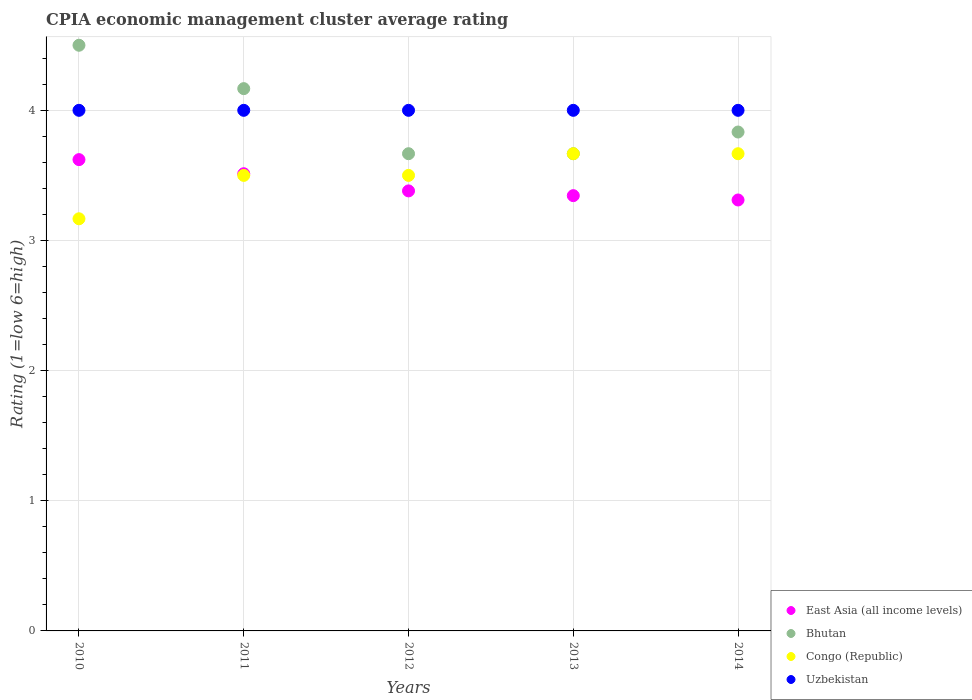How many different coloured dotlines are there?
Give a very brief answer. 4. Is the number of dotlines equal to the number of legend labels?
Make the answer very short. Yes. Across all years, what is the maximum CPIA rating in Uzbekistan?
Provide a succinct answer. 4. Across all years, what is the minimum CPIA rating in Bhutan?
Offer a very short reply. 3.67. In which year was the CPIA rating in Uzbekistan minimum?
Your answer should be very brief. 2010. What is the difference between the CPIA rating in Uzbekistan in 2012 and that in 2014?
Your answer should be compact. 0. What is the difference between the CPIA rating in Bhutan in 2011 and the CPIA rating in Uzbekistan in 2014?
Keep it short and to the point. 0.17. What is the average CPIA rating in Uzbekistan per year?
Your answer should be very brief. 4. In the year 2011, what is the difference between the CPIA rating in Uzbekistan and CPIA rating in Bhutan?
Your response must be concise. -0.17. What is the difference between the highest and the second highest CPIA rating in Uzbekistan?
Offer a very short reply. 0. What is the difference between the highest and the lowest CPIA rating in East Asia (all income levels)?
Your answer should be compact. 0.31. In how many years, is the CPIA rating in Uzbekistan greater than the average CPIA rating in Uzbekistan taken over all years?
Make the answer very short. 0. Is the sum of the CPIA rating in Uzbekistan in 2010 and 2012 greater than the maximum CPIA rating in Bhutan across all years?
Your answer should be compact. Yes. Does the CPIA rating in Uzbekistan monotonically increase over the years?
Make the answer very short. No. Is the CPIA rating in Uzbekistan strictly greater than the CPIA rating in Congo (Republic) over the years?
Provide a short and direct response. Yes. Is the CPIA rating in East Asia (all income levels) strictly less than the CPIA rating in Congo (Republic) over the years?
Make the answer very short. No. How many dotlines are there?
Your answer should be very brief. 4. How many years are there in the graph?
Your answer should be compact. 5. What is the difference between two consecutive major ticks on the Y-axis?
Offer a terse response. 1. What is the title of the graph?
Give a very brief answer. CPIA economic management cluster average rating. Does "Austria" appear as one of the legend labels in the graph?
Your response must be concise. No. What is the label or title of the X-axis?
Offer a terse response. Years. What is the label or title of the Y-axis?
Offer a terse response. Rating (1=low 6=high). What is the Rating (1=low 6=high) of East Asia (all income levels) in 2010?
Make the answer very short. 3.62. What is the Rating (1=low 6=high) in Bhutan in 2010?
Give a very brief answer. 4.5. What is the Rating (1=low 6=high) in Congo (Republic) in 2010?
Offer a very short reply. 3.17. What is the Rating (1=low 6=high) of Uzbekistan in 2010?
Your answer should be very brief. 4. What is the Rating (1=low 6=high) in East Asia (all income levels) in 2011?
Your answer should be compact. 3.51. What is the Rating (1=low 6=high) in Bhutan in 2011?
Your response must be concise. 4.17. What is the Rating (1=low 6=high) of Congo (Republic) in 2011?
Keep it short and to the point. 3.5. What is the Rating (1=low 6=high) in East Asia (all income levels) in 2012?
Your answer should be very brief. 3.38. What is the Rating (1=low 6=high) in Bhutan in 2012?
Your response must be concise. 3.67. What is the Rating (1=low 6=high) of Uzbekistan in 2012?
Make the answer very short. 4. What is the Rating (1=low 6=high) of East Asia (all income levels) in 2013?
Provide a short and direct response. 3.34. What is the Rating (1=low 6=high) of Bhutan in 2013?
Offer a terse response. 3.67. What is the Rating (1=low 6=high) of Congo (Republic) in 2013?
Keep it short and to the point. 3.67. What is the Rating (1=low 6=high) in East Asia (all income levels) in 2014?
Offer a very short reply. 3.31. What is the Rating (1=low 6=high) in Bhutan in 2014?
Offer a terse response. 3.83. What is the Rating (1=low 6=high) of Congo (Republic) in 2014?
Offer a terse response. 3.67. Across all years, what is the maximum Rating (1=low 6=high) of East Asia (all income levels)?
Provide a succinct answer. 3.62. Across all years, what is the maximum Rating (1=low 6=high) of Bhutan?
Your response must be concise. 4.5. Across all years, what is the maximum Rating (1=low 6=high) in Congo (Republic)?
Keep it short and to the point. 3.67. Across all years, what is the minimum Rating (1=low 6=high) of East Asia (all income levels)?
Provide a succinct answer. 3.31. Across all years, what is the minimum Rating (1=low 6=high) in Bhutan?
Ensure brevity in your answer.  3.67. Across all years, what is the minimum Rating (1=low 6=high) in Congo (Republic)?
Your answer should be compact. 3.17. What is the total Rating (1=low 6=high) of East Asia (all income levels) in the graph?
Offer a very short reply. 17.17. What is the total Rating (1=low 6=high) of Bhutan in the graph?
Keep it short and to the point. 19.83. What is the total Rating (1=low 6=high) of Uzbekistan in the graph?
Provide a short and direct response. 20. What is the difference between the Rating (1=low 6=high) in East Asia (all income levels) in 2010 and that in 2011?
Offer a very short reply. 0.11. What is the difference between the Rating (1=low 6=high) in Bhutan in 2010 and that in 2011?
Ensure brevity in your answer.  0.33. What is the difference between the Rating (1=low 6=high) of East Asia (all income levels) in 2010 and that in 2012?
Provide a short and direct response. 0.24. What is the difference between the Rating (1=low 6=high) of Bhutan in 2010 and that in 2012?
Ensure brevity in your answer.  0.83. What is the difference between the Rating (1=low 6=high) of East Asia (all income levels) in 2010 and that in 2013?
Your answer should be compact. 0.28. What is the difference between the Rating (1=low 6=high) in Bhutan in 2010 and that in 2013?
Provide a succinct answer. 0.83. What is the difference between the Rating (1=low 6=high) in Congo (Republic) in 2010 and that in 2013?
Your response must be concise. -0.5. What is the difference between the Rating (1=low 6=high) in Uzbekistan in 2010 and that in 2013?
Offer a terse response. 0. What is the difference between the Rating (1=low 6=high) of East Asia (all income levels) in 2010 and that in 2014?
Your response must be concise. 0.31. What is the difference between the Rating (1=low 6=high) in Bhutan in 2010 and that in 2014?
Ensure brevity in your answer.  0.67. What is the difference between the Rating (1=low 6=high) of East Asia (all income levels) in 2011 and that in 2012?
Give a very brief answer. 0.13. What is the difference between the Rating (1=low 6=high) of Bhutan in 2011 and that in 2012?
Provide a short and direct response. 0.5. What is the difference between the Rating (1=low 6=high) in Congo (Republic) in 2011 and that in 2012?
Offer a terse response. 0. What is the difference between the Rating (1=low 6=high) of Uzbekistan in 2011 and that in 2012?
Make the answer very short. 0. What is the difference between the Rating (1=low 6=high) of East Asia (all income levels) in 2011 and that in 2013?
Ensure brevity in your answer.  0.17. What is the difference between the Rating (1=low 6=high) in Bhutan in 2011 and that in 2013?
Offer a terse response. 0.5. What is the difference between the Rating (1=low 6=high) of East Asia (all income levels) in 2011 and that in 2014?
Offer a very short reply. 0.2. What is the difference between the Rating (1=low 6=high) in East Asia (all income levels) in 2012 and that in 2013?
Your response must be concise. 0.04. What is the difference between the Rating (1=low 6=high) in Bhutan in 2012 and that in 2013?
Make the answer very short. 0. What is the difference between the Rating (1=low 6=high) in Congo (Republic) in 2012 and that in 2013?
Provide a succinct answer. -0.17. What is the difference between the Rating (1=low 6=high) of East Asia (all income levels) in 2012 and that in 2014?
Ensure brevity in your answer.  0.07. What is the difference between the Rating (1=low 6=high) in Uzbekistan in 2012 and that in 2014?
Offer a very short reply. 0. What is the difference between the Rating (1=low 6=high) in East Asia (all income levels) in 2010 and the Rating (1=low 6=high) in Bhutan in 2011?
Provide a short and direct response. -0.55. What is the difference between the Rating (1=low 6=high) in East Asia (all income levels) in 2010 and the Rating (1=low 6=high) in Congo (Republic) in 2011?
Ensure brevity in your answer.  0.12. What is the difference between the Rating (1=low 6=high) of East Asia (all income levels) in 2010 and the Rating (1=low 6=high) of Uzbekistan in 2011?
Your response must be concise. -0.38. What is the difference between the Rating (1=low 6=high) in Bhutan in 2010 and the Rating (1=low 6=high) in Uzbekistan in 2011?
Provide a short and direct response. 0.5. What is the difference between the Rating (1=low 6=high) of East Asia (all income levels) in 2010 and the Rating (1=low 6=high) of Bhutan in 2012?
Your answer should be compact. -0.05. What is the difference between the Rating (1=low 6=high) of East Asia (all income levels) in 2010 and the Rating (1=low 6=high) of Congo (Republic) in 2012?
Keep it short and to the point. 0.12. What is the difference between the Rating (1=low 6=high) in East Asia (all income levels) in 2010 and the Rating (1=low 6=high) in Uzbekistan in 2012?
Your response must be concise. -0.38. What is the difference between the Rating (1=low 6=high) of Bhutan in 2010 and the Rating (1=low 6=high) of Congo (Republic) in 2012?
Offer a terse response. 1. What is the difference between the Rating (1=low 6=high) in Bhutan in 2010 and the Rating (1=low 6=high) in Uzbekistan in 2012?
Your answer should be compact. 0.5. What is the difference between the Rating (1=low 6=high) of Congo (Republic) in 2010 and the Rating (1=low 6=high) of Uzbekistan in 2012?
Give a very brief answer. -0.83. What is the difference between the Rating (1=low 6=high) of East Asia (all income levels) in 2010 and the Rating (1=low 6=high) of Bhutan in 2013?
Offer a terse response. -0.05. What is the difference between the Rating (1=low 6=high) of East Asia (all income levels) in 2010 and the Rating (1=low 6=high) of Congo (Republic) in 2013?
Keep it short and to the point. -0.05. What is the difference between the Rating (1=low 6=high) of East Asia (all income levels) in 2010 and the Rating (1=low 6=high) of Uzbekistan in 2013?
Your answer should be very brief. -0.38. What is the difference between the Rating (1=low 6=high) in East Asia (all income levels) in 2010 and the Rating (1=low 6=high) in Bhutan in 2014?
Your answer should be very brief. -0.21. What is the difference between the Rating (1=low 6=high) of East Asia (all income levels) in 2010 and the Rating (1=low 6=high) of Congo (Republic) in 2014?
Offer a terse response. -0.05. What is the difference between the Rating (1=low 6=high) in East Asia (all income levels) in 2010 and the Rating (1=low 6=high) in Uzbekistan in 2014?
Offer a terse response. -0.38. What is the difference between the Rating (1=low 6=high) in Bhutan in 2010 and the Rating (1=low 6=high) in Congo (Republic) in 2014?
Your answer should be very brief. 0.83. What is the difference between the Rating (1=low 6=high) of Bhutan in 2010 and the Rating (1=low 6=high) of Uzbekistan in 2014?
Offer a very short reply. 0.5. What is the difference between the Rating (1=low 6=high) in East Asia (all income levels) in 2011 and the Rating (1=low 6=high) in Bhutan in 2012?
Keep it short and to the point. -0.15. What is the difference between the Rating (1=low 6=high) in East Asia (all income levels) in 2011 and the Rating (1=low 6=high) in Congo (Republic) in 2012?
Your answer should be very brief. 0.01. What is the difference between the Rating (1=low 6=high) in East Asia (all income levels) in 2011 and the Rating (1=low 6=high) in Uzbekistan in 2012?
Give a very brief answer. -0.49. What is the difference between the Rating (1=low 6=high) in Bhutan in 2011 and the Rating (1=low 6=high) in Uzbekistan in 2012?
Your answer should be compact. 0.17. What is the difference between the Rating (1=low 6=high) in East Asia (all income levels) in 2011 and the Rating (1=low 6=high) in Bhutan in 2013?
Offer a terse response. -0.15. What is the difference between the Rating (1=low 6=high) in East Asia (all income levels) in 2011 and the Rating (1=low 6=high) in Congo (Republic) in 2013?
Provide a short and direct response. -0.15. What is the difference between the Rating (1=low 6=high) in East Asia (all income levels) in 2011 and the Rating (1=low 6=high) in Uzbekistan in 2013?
Keep it short and to the point. -0.49. What is the difference between the Rating (1=low 6=high) of Bhutan in 2011 and the Rating (1=low 6=high) of Congo (Republic) in 2013?
Offer a terse response. 0.5. What is the difference between the Rating (1=low 6=high) in East Asia (all income levels) in 2011 and the Rating (1=low 6=high) in Bhutan in 2014?
Give a very brief answer. -0.32. What is the difference between the Rating (1=low 6=high) of East Asia (all income levels) in 2011 and the Rating (1=low 6=high) of Congo (Republic) in 2014?
Make the answer very short. -0.15. What is the difference between the Rating (1=low 6=high) in East Asia (all income levels) in 2011 and the Rating (1=low 6=high) in Uzbekistan in 2014?
Keep it short and to the point. -0.49. What is the difference between the Rating (1=low 6=high) of East Asia (all income levels) in 2012 and the Rating (1=low 6=high) of Bhutan in 2013?
Offer a very short reply. -0.29. What is the difference between the Rating (1=low 6=high) of East Asia (all income levels) in 2012 and the Rating (1=low 6=high) of Congo (Republic) in 2013?
Offer a very short reply. -0.29. What is the difference between the Rating (1=low 6=high) in East Asia (all income levels) in 2012 and the Rating (1=low 6=high) in Uzbekistan in 2013?
Offer a very short reply. -0.62. What is the difference between the Rating (1=low 6=high) in Bhutan in 2012 and the Rating (1=low 6=high) in Uzbekistan in 2013?
Your response must be concise. -0.33. What is the difference between the Rating (1=low 6=high) of Congo (Republic) in 2012 and the Rating (1=low 6=high) of Uzbekistan in 2013?
Keep it short and to the point. -0.5. What is the difference between the Rating (1=low 6=high) of East Asia (all income levels) in 2012 and the Rating (1=low 6=high) of Bhutan in 2014?
Provide a succinct answer. -0.45. What is the difference between the Rating (1=low 6=high) of East Asia (all income levels) in 2012 and the Rating (1=low 6=high) of Congo (Republic) in 2014?
Your response must be concise. -0.29. What is the difference between the Rating (1=low 6=high) of East Asia (all income levels) in 2012 and the Rating (1=low 6=high) of Uzbekistan in 2014?
Your answer should be very brief. -0.62. What is the difference between the Rating (1=low 6=high) of Congo (Republic) in 2012 and the Rating (1=low 6=high) of Uzbekistan in 2014?
Provide a short and direct response. -0.5. What is the difference between the Rating (1=low 6=high) in East Asia (all income levels) in 2013 and the Rating (1=low 6=high) in Bhutan in 2014?
Keep it short and to the point. -0.49. What is the difference between the Rating (1=low 6=high) of East Asia (all income levels) in 2013 and the Rating (1=low 6=high) of Congo (Republic) in 2014?
Keep it short and to the point. -0.32. What is the difference between the Rating (1=low 6=high) of East Asia (all income levels) in 2013 and the Rating (1=low 6=high) of Uzbekistan in 2014?
Ensure brevity in your answer.  -0.66. What is the difference between the Rating (1=low 6=high) in Bhutan in 2013 and the Rating (1=low 6=high) in Uzbekistan in 2014?
Offer a very short reply. -0.33. What is the difference between the Rating (1=low 6=high) in Congo (Republic) in 2013 and the Rating (1=low 6=high) in Uzbekistan in 2014?
Your response must be concise. -0.33. What is the average Rating (1=low 6=high) of East Asia (all income levels) per year?
Offer a terse response. 3.43. What is the average Rating (1=low 6=high) in Bhutan per year?
Your answer should be compact. 3.97. What is the average Rating (1=low 6=high) of Congo (Republic) per year?
Offer a terse response. 3.5. In the year 2010, what is the difference between the Rating (1=low 6=high) of East Asia (all income levels) and Rating (1=low 6=high) of Bhutan?
Offer a very short reply. -0.88. In the year 2010, what is the difference between the Rating (1=low 6=high) of East Asia (all income levels) and Rating (1=low 6=high) of Congo (Republic)?
Your answer should be very brief. 0.45. In the year 2010, what is the difference between the Rating (1=low 6=high) in East Asia (all income levels) and Rating (1=low 6=high) in Uzbekistan?
Your response must be concise. -0.38. In the year 2010, what is the difference between the Rating (1=low 6=high) in Congo (Republic) and Rating (1=low 6=high) in Uzbekistan?
Your answer should be compact. -0.83. In the year 2011, what is the difference between the Rating (1=low 6=high) of East Asia (all income levels) and Rating (1=low 6=high) of Bhutan?
Provide a short and direct response. -0.65. In the year 2011, what is the difference between the Rating (1=low 6=high) in East Asia (all income levels) and Rating (1=low 6=high) in Congo (Republic)?
Offer a very short reply. 0.01. In the year 2011, what is the difference between the Rating (1=low 6=high) of East Asia (all income levels) and Rating (1=low 6=high) of Uzbekistan?
Your answer should be very brief. -0.49. In the year 2011, what is the difference between the Rating (1=low 6=high) of Congo (Republic) and Rating (1=low 6=high) of Uzbekistan?
Ensure brevity in your answer.  -0.5. In the year 2012, what is the difference between the Rating (1=low 6=high) in East Asia (all income levels) and Rating (1=low 6=high) in Bhutan?
Make the answer very short. -0.29. In the year 2012, what is the difference between the Rating (1=low 6=high) of East Asia (all income levels) and Rating (1=low 6=high) of Congo (Republic)?
Provide a succinct answer. -0.12. In the year 2012, what is the difference between the Rating (1=low 6=high) of East Asia (all income levels) and Rating (1=low 6=high) of Uzbekistan?
Give a very brief answer. -0.62. In the year 2013, what is the difference between the Rating (1=low 6=high) in East Asia (all income levels) and Rating (1=low 6=high) in Bhutan?
Offer a very short reply. -0.32. In the year 2013, what is the difference between the Rating (1=low 6=high) of East Asia (all income levels) and Rating (1=low 6=high) of Congo (Republic)?
Make the answer very short. -0.32. In the year 2013, what is the difference between the Rating (1=low 6=high) of East Asia (all income levels) and Rating (1=low 6=high) of Uzbekistan?
Give a very brief answer. -0.66. In the year 2013, what is the difference between the Rating (1=low 6=high) in Bhutan and Rating (1=low 6=high) in Congo (Republic)?
Keep it short and to the point. 0. In the year 2013, what is the difference between the Rating (1=low 6=high) of Bhutan and Rating (1=low 6=high) of Uzbekistan?
Provide a short and direct response. -0.33. In the year 2014, what is the difference between the Rating (1=low 6=high) of East Asia (all income levels) and Rating (1=low 6=high) of Bhutan?
Make the answer very short. -0.52. In the year 2014, what is the difference between the Rating (1=low 6=high) of East Asia (all income levels) and Rating (1=low 6=high) of Congo (Republic)?
Make the answer very short. -0.36. In the year 2014, what is the difference between the Rating (1=low 6=high) in East Asia (all income levels) and Rating (1=low 6=high) in Uzbekistan?
Offer a terse response. -0.69. In the year 2014, what is the difference between the Rating (1=low 6=high) in Bhutan and Rating (1=low 6=high) in Uzbekistan?
Provide a short and direct response. -0.17. What is the ratio of the Rating (1=low 6=high) of East Asia (all income levels) in 2010 to that in 2011?
Give a very brief answer. 1.03. What is the ratio of the Rating (1=low 6=high) of Bhutan in 2010 to that in 2011?
Your response must be concise. 1.08. What is the ratio of the Rating (1=low 6=high) in Congo (Republic) in 2010 to that in 2011?
Provide a succinct answer. 0.9. What is the ratio of the Rating (1=low 6=high) in Uzbekistan in 2010 to that in 2011?
Make the answer very short. 1. What is the ratio of the Rating (1=low 6=high) in East Asia (all income levels) in 2010 to that in 2012?
Your answer should be compact. 1.07. What is the ratio of the Rating (1=low 6=high) in Bhutan in 2010 to that in 2012?
Provide a succinct answer. 1.23. What is the ratio of the Rating (1=low 6=high) in Congo (Republic) in 2010 to that in 2012?
Ensure brevity in your answer.  0.9. What is the ratio of the Rating (1=low 6=high) in East Asia (all income levels) in 2010 to that in 2013?
Make the answer very short. 1.08. What is the ratio of the Rating (1=low 6=high) of Bhutan in 2010 to that in 2013?
Make the answer very short. 1.23. What is the ratio of the Rating (1=low 6=high) in Congo (Republic) in 2010 to that in 2013?
Keep it short and to the point. 0.86. What is the ratio of the Rating (1=low 6=high) of Uzbekistan in 2010 to that in 2013?
Your answer should be very brief. 1. What is the ratio of the Rating (1=low 6=high) in East Asia (all income levels) in 2010 to that in 2014?
Offer a very short reply. 1.09. What is the ratio of the Rating (1=low 6=high) in Bhutan in 2010 to that in 2014?
Ensure brevity in your answer.  1.17. What is the ratio of the Rating (1=low 6=high) in Congo (Republic) in 2010 to that in 2014?
Give a very brief answer. 0.86. What is the ratio of the Rating (1=low 6=high) in Uzbekistan in 2010 to that in 2014?
Offer a terse response. 1. What is the ratio of the Rating (1=low 6=high) in East Asia (all income levels) in 2011 to that in 2012?
Provide a short and direct response. 1.04. What is the ratio of the Rating (1=low 6=high) in Bhutan in 2011 to that in 2012?
Your answer should be compact. 1.14. What is the ratio of the Rating (1=low 6=high) in Uzbekistan in 2011 to that in 2012?
Make the answer very short. 1. What is the ratio of the Rating (1=low 6=high) in East Asia (all income levels) in 2011 to that in 2013?
Offer a very short reply. 1.05. What is the ratio of the Rating (1=low 6=high) of Bhutan in 2011 to that in 2013?
Offer a very short reply. 1.14. What is the ratio of the Rating (1=low 6=high) in Congo (Republic) in 2011 to that in 2013?
Keep it short and to the point. 0.95. What is the ratio of the Rating (1=low 6=high) in East Asia (all income levels) in 2011 to that in 2014?
Give a very brief answer. 1.06. What is the ratio of the Rating (1=low 6=high) in Bhutan in 2011 to that in 2014?
Your response must be concise. 1.09. What is the ratio of the Rating (1=low 6=high) in Congo (Republic) in 2011 to that in 2014?
Your answer should be compact. 0.95. What is the ratio of the Rating (1=low 6=high) of East Asia (all income levels) in 2012 to that in 2013?
Offer a terse response. 1.01. What is the ratio of the Rating (1=low 6=high) in Congo (Republic) in 2012 to that in 2013?
Give a very brief answer. 0.95. What is the ratio of the Rating (1=low 6=high) in Uzbekistan in 2012 to that in 2013?
Make the answer very short. 1. What is the ratio of the Rating (1=low 6=high) of East Asia (all income levels) in 2012 to that in 2014?
Make the answer very short. 1.02. What is the ratio of the Rating (1=low 6=high) of Bhutan in 2012 to that in 2014?
Keep it short and to the point. 0.96. What is the ratio of the Rating (1=low 6=high) in Congo (Republic) in 2012 to that in 2014?
Your answer should be very brief. 0.95. What is the ratio of the Rating (1=low 6=high) in East Asia (all income levels) in 2013 to that in 2014?
Your answer should be very brief. 1.01. What is the ratio of the Rating (1=low 6=high) in Bhutan in 2013 to that in 2014?
Your answer should be very brief. 0.96. What is the ratio of the Rating (1=low 6=high) of Uzbekistan in 2013 to that in 2014?
Keep it short and to the point. 1. What is the difference between the highest and the second highest Rating (1=low 6=high) in East Asia (all income levels)?
Provide a short and direct response. 0.11. What is the difference between the highest and the second highest Rating (1=low 6=high) in Bhutan?
Keep it short and to the point. 0.33. What is the difference between the highest and the second highest Rating (1=low 6=high) in Uzbekistan?
Your answer should be very brief. 0. What is the difference between the highest and the lowest Rating (1=low 6=high) of East Asia (all income levels)?
Your answer should be compact. 0.31. What is the difference between the highest and the lowest Rating (1=low 6=high) in Congo (Republic)?
Your answer should be very brief. 0.5. 